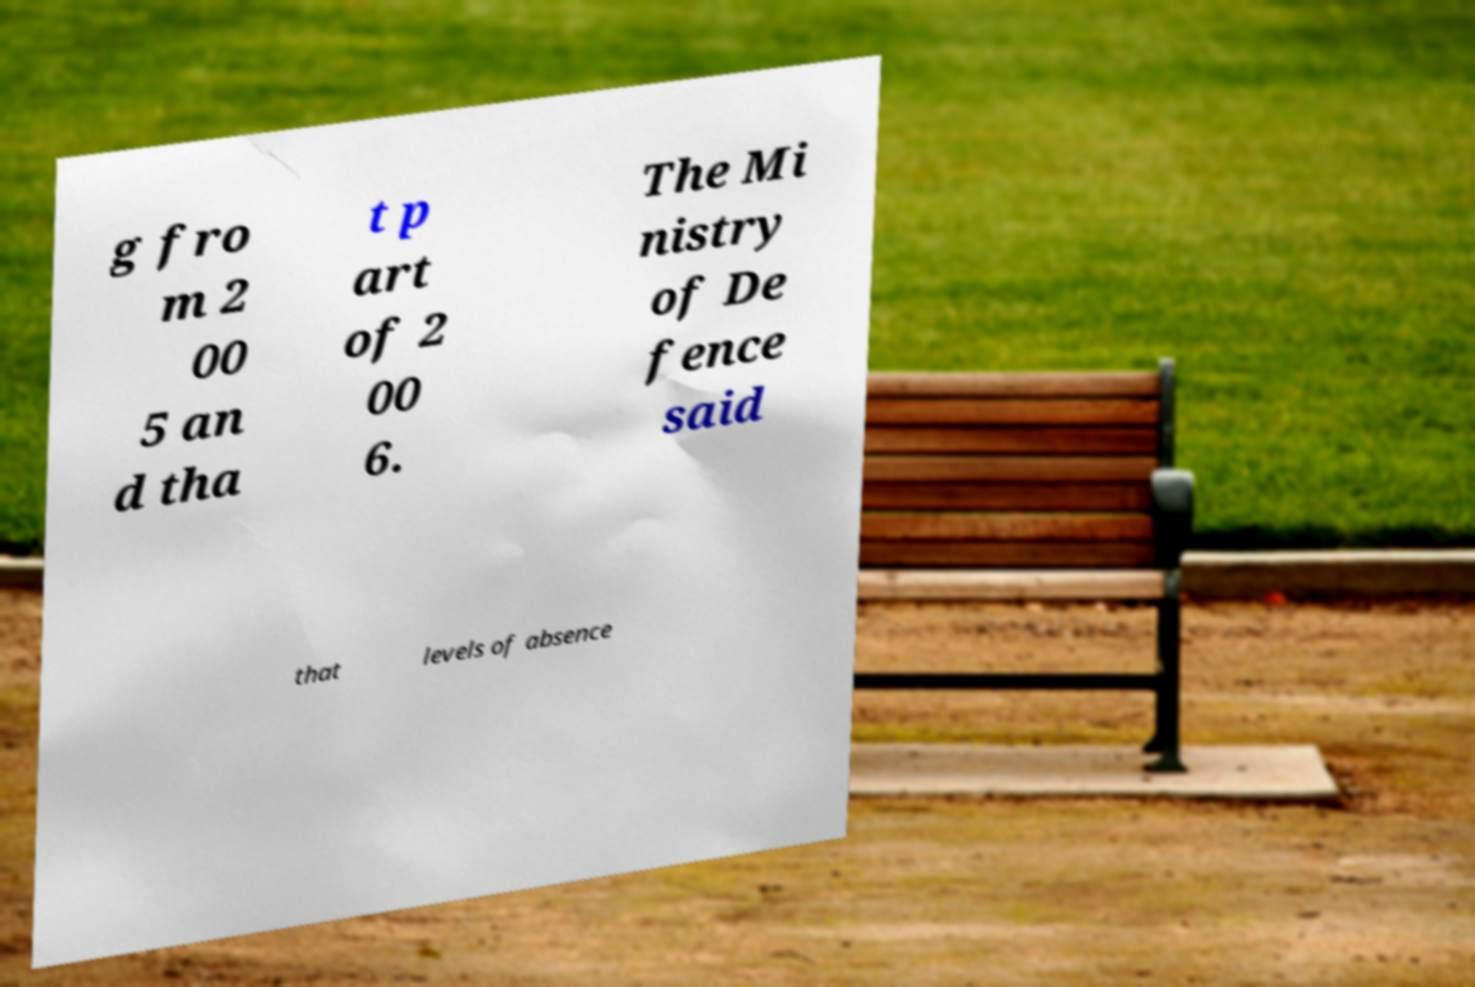What messages or text are displayed in this image? I need them in a readable, typed format. g fro m 2 00 5 an d tha t p art of 2 00 6. The Mi nistry of De fence said that levels of absence 